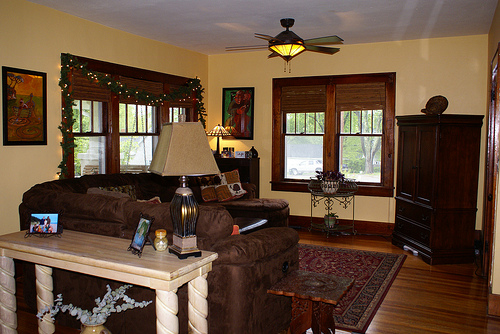Please provide the bounding box coordinate of the region this sentence describes: A white floral arrangement in a vase. Coordinates: [0.07, 0.73, 0.32, 0.83]. The region shows a white floral arrangement beautifully placed in a vase. 